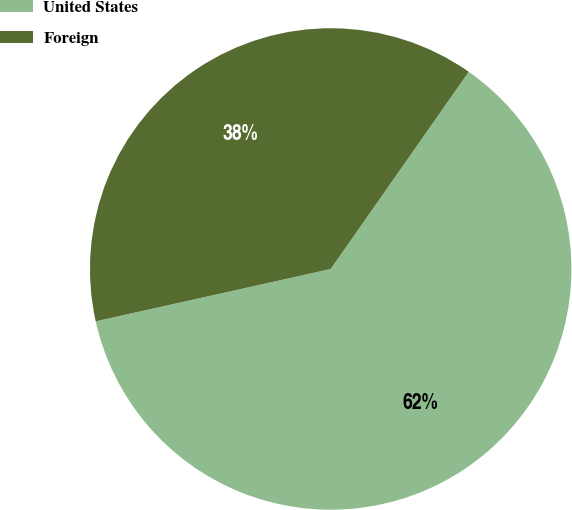Convert chart. <chart><loc_0><loc_0><loc_500><loc_500><pie_chart><fcel>United States<fcel>Foreign<nl><fcel>61.79%<fcel>38.21%<nl></chart> 